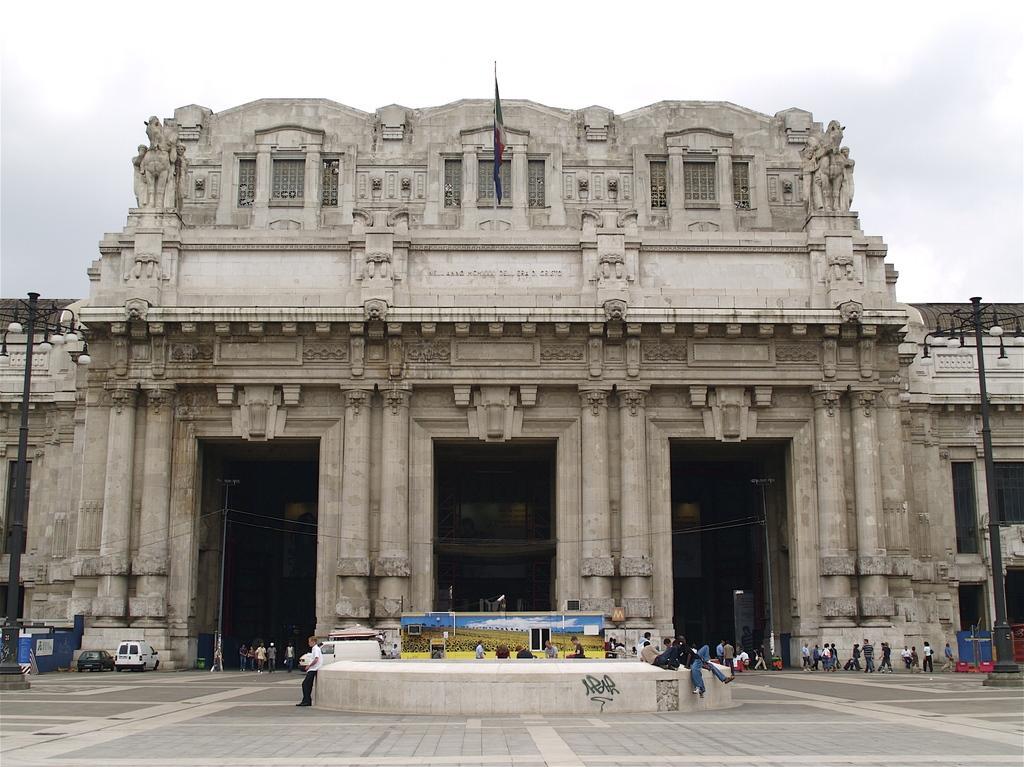Describe this image in one or two sentences. In this image I can see the ground, few persons standing on the ground, few vehicles on the ground, two black colored poles, few blue colored bins on the ground , a banner which is yellow and blue in color and a building which is cream and brown in color. I can see a flag to the building and in the background I can see the sky. 